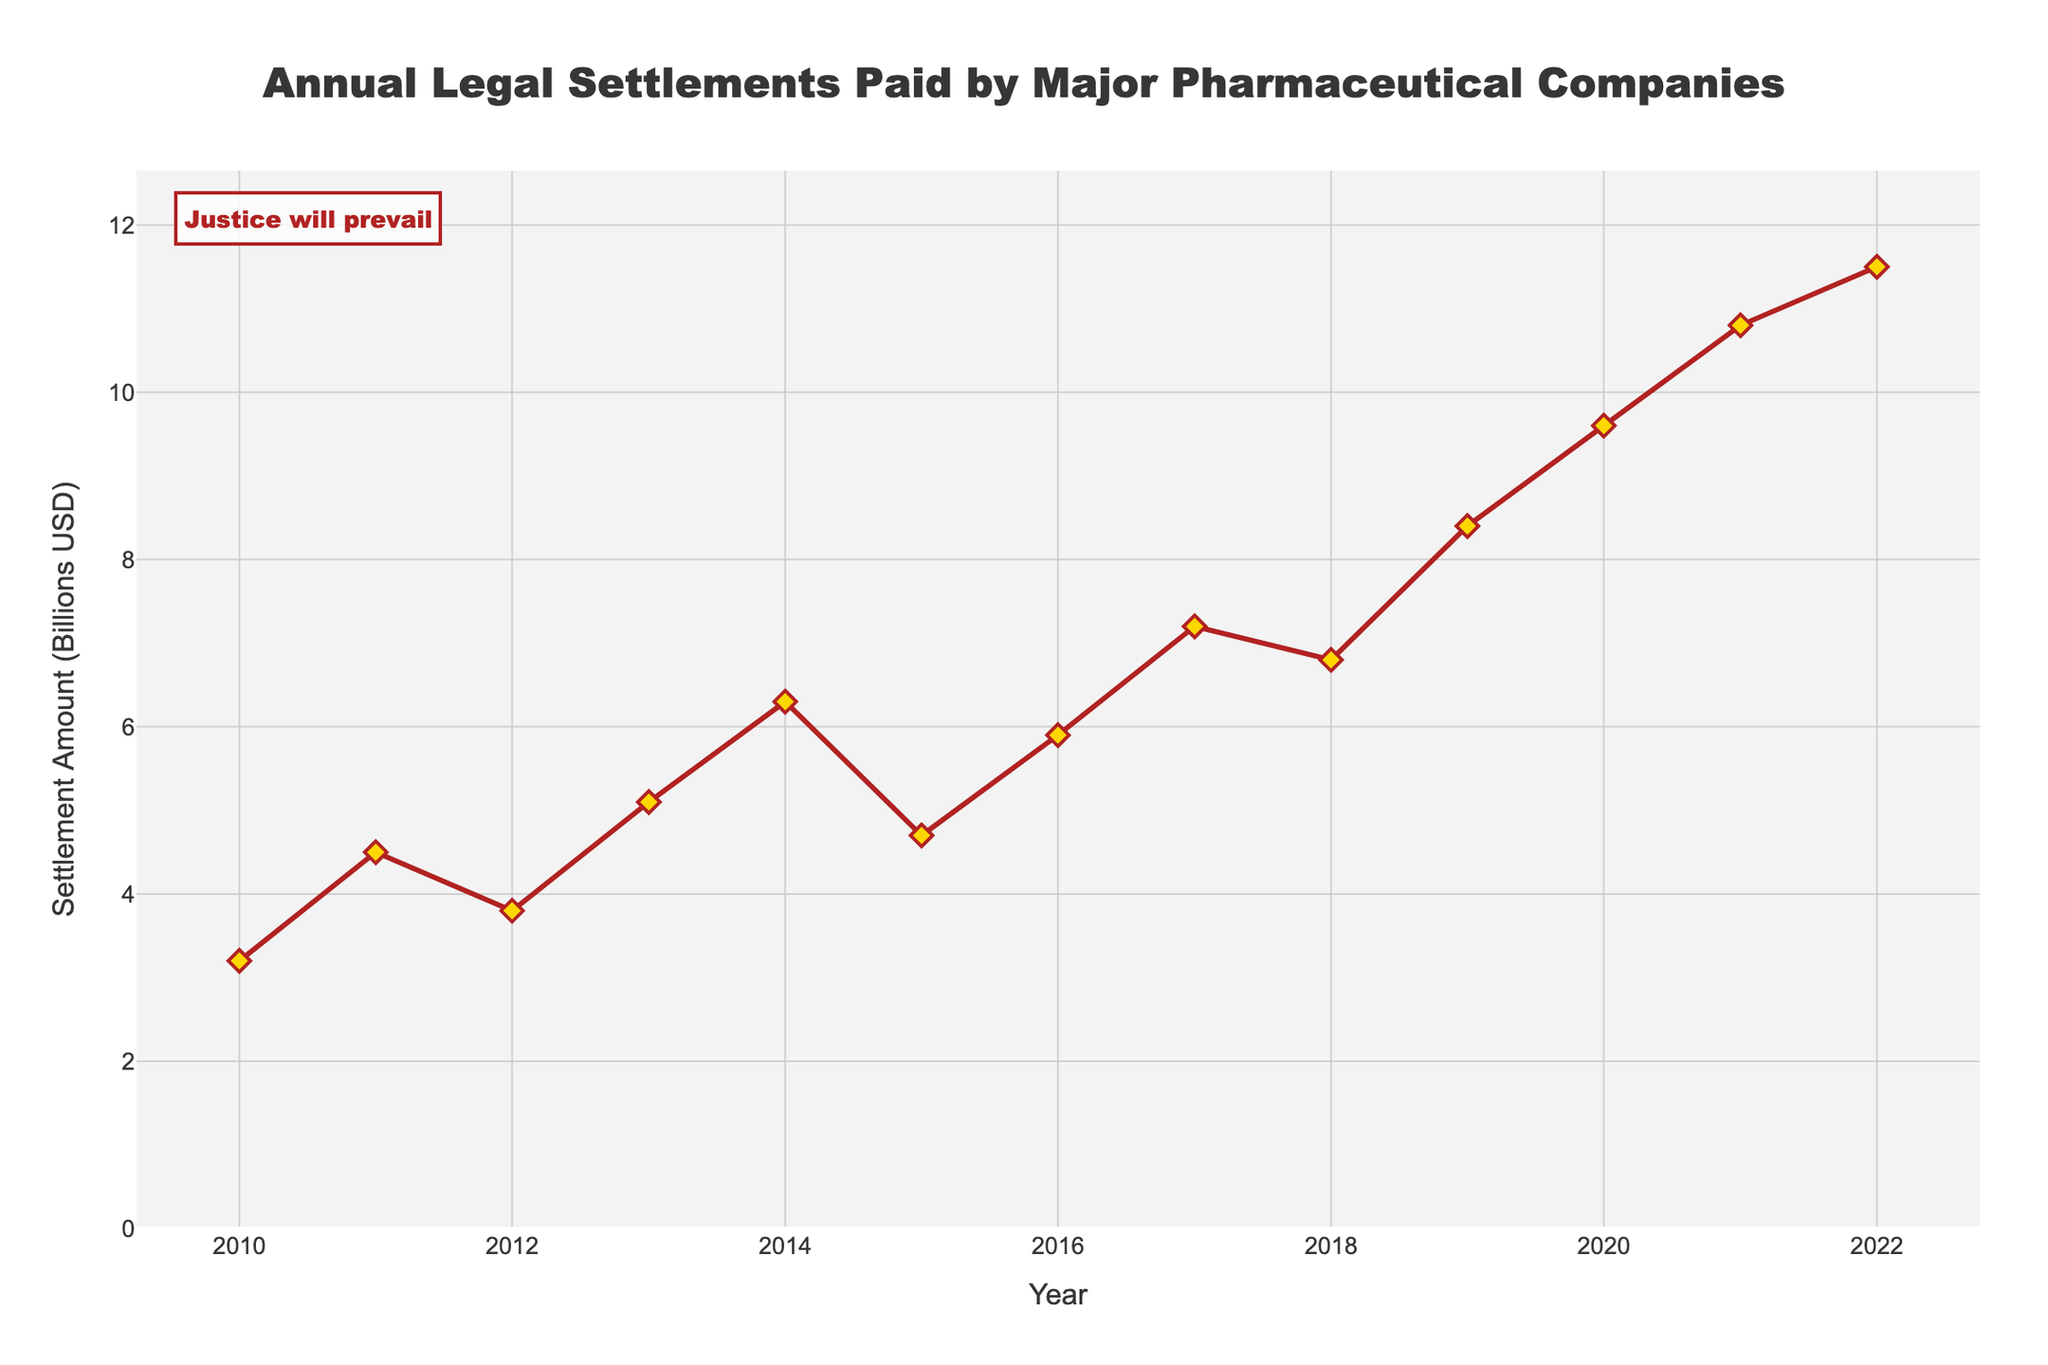What is the highest settlement amount recorded in the chart? The highest point on the line chart represents the maximum settlement amount recorded. In 2022, the settlement amount is at its peak with 11.5 billion USD.
Answer: 11.5 billion USD How has the annual settlement amount changed from 2010 to 2022? To determine the change, find the settlement amounts for 2010 and 2022 and compute the difference. In 2010, the settlement amount was 3.2 billion USD, and in 2022, it was 11.5 billion USD. The difference is 11.5 - 3.2 = 8.3 billion USD.
Answer: Increased by 8.3 billion USD In which year did the settlement amount first exceed 7 billion USD? Locate the first point at which the settlement amount crosses the 7 billion USD threshold in the line chart. The data shows that this occurs in 2017 with 7.2 billion USD.
Answer: 2017 What is the average annual settlement amount from 2010 to 2022? Sum all the settlement amounts from each year from 2010 to 2022, then divide by the number of years: (3.2 + 4.5 + 3.8 + 5.1 + 6.3 + 4.7 + 5.9 + 7.2 + 6.8 + 8.4 + 9.6 + 10.8 + 11.5) / 13 = 7.0 billion USD.
Answer: 7.0 billion USD How does the settlement amount in 2015 compare to 2020? Identify the settlement amounts for both 2015 (4.7 billion USD) and 2020 (9.6 billion USD). The settlement amount in 2020 is higher than in 2015.
Answer: 2020 is higher What is the trend in settlement amounts over the years? Examine the line chart to identify general patterns. The settlement amounts show an upward trend with fluctuations, indicating an overall increase from 2010 to 2022.
Answer: Increasing Which year experienced the largest year-over-year increase in settlement amount? Calculate the year-over-year differences for each year: 
2011-2010: 1.3, 2012-2011: -0.7, 2013-2012: 1.3, 2014-2013: 1.2, 2015-2014: -1.6, 2016-2015: 1.2, 2017-2016: 1.3, 2018-2017: -0.4, 2019-2018: 1.6, 2020-2019: 1.2, 2021-2020: 1.2, 2022-2021: 0.7. The largest increase is from 2019 to 2020 with 1.6 billion USD.
Answer: 2019 to 2020 What is the median settlement amount from 2010 to 2022? Arrange the settlement amounts in ascending order and find the middle value: (3.2, 3.8, 4.5, 4.7, 5.1, 5.9, 6.3, 6.8, 7.2, 8.4, 9.6, 10.8, 11.5). The median is the 7th value, which is 6.3 billion USD.
Answer: 6.3 billion USD What color are the markers on the graph? Observe the visual characteristics of the markers on the line chart. The markers are yellow diamonds with a red outline.
Answer: Yellow with red outline 